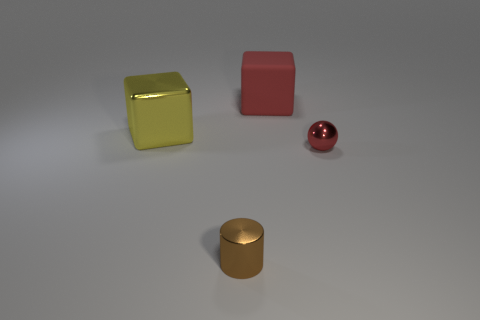Add 3 big red shiny cubes. How many objects exist? 7 Subtract all small brown shiny objects. Subtract all small brown metal cylinders. How many objects are left? 2 Add 2 small brown metal cylinders. How many small brown metal cylinders are left? 3 Add 1 tiny red spheres. How many tiny red spheres exist? 2 Subtract 0 green balls. How many objects are left? 4 Subtract all cylinders. How many objects are left? 3 